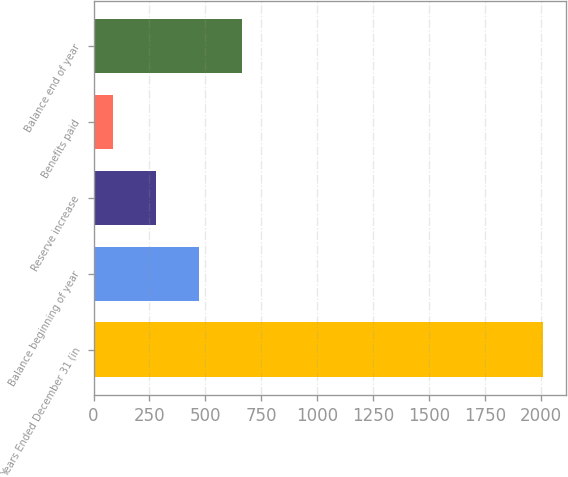Convert chart to OTSL. <chart><loc_0><loc_0><loc_500><loc_500><bar_chart><fcel>Years Ended December 31 (in<fcel>Balance beginning of year<fcel>Reserve increase<fcel>Benefits paid<fcel>Balance end of year<nl><fcel>2011<fcel>471.8<fcel>279.4<fcel>87<fcel>664.2<nl></chart> 